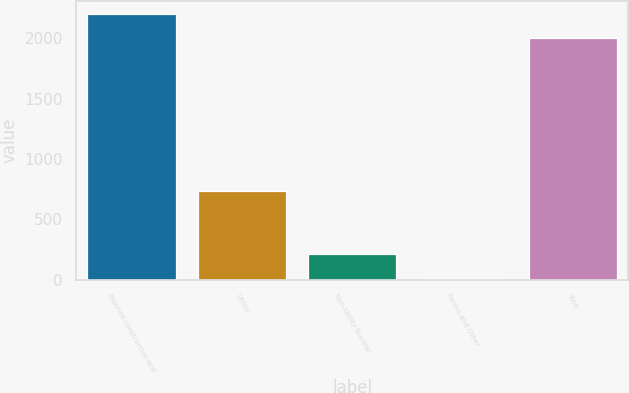Convert chart. <chart><loc_0><loc_0><loc_500><loc_500><bar_chart><fcel>Planned construction and<fcel>Utility<fcel>Non-Utility Nuclear<fcel>Parent and Other<fcel>Total<nl><fcel>2199.1<fcel>738<fcel>208.1<fcel>8<fcel>1999<nl></chart> 